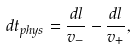Convert formula to latex. <formula><loc_0><loc_0><loc_500><loc_500>d t _ { p h y s } = \frac { d l } { v _ { - } } - \frac { d l } { v _ { + } } ,</formula> 